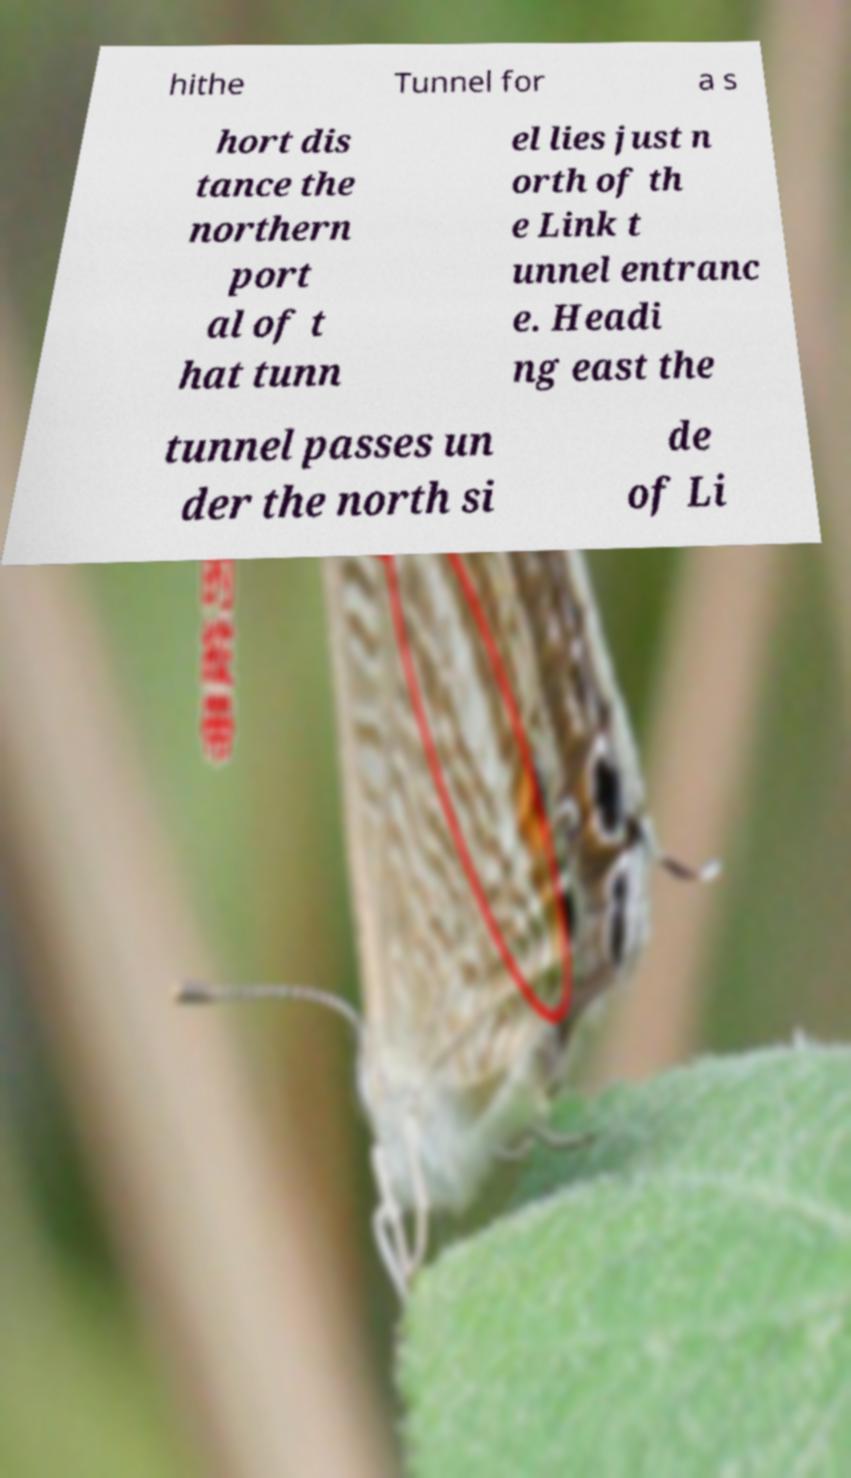There's text embedded in this image that I need extracted. Can you transcribe it verbatim? hithe Tunnel for a s hort dis tance the northern port al of t hat tunn el lies just n orth of th e Link t unnel entranc e. Headi ng east the tunnel passes un der the north si de of Li 